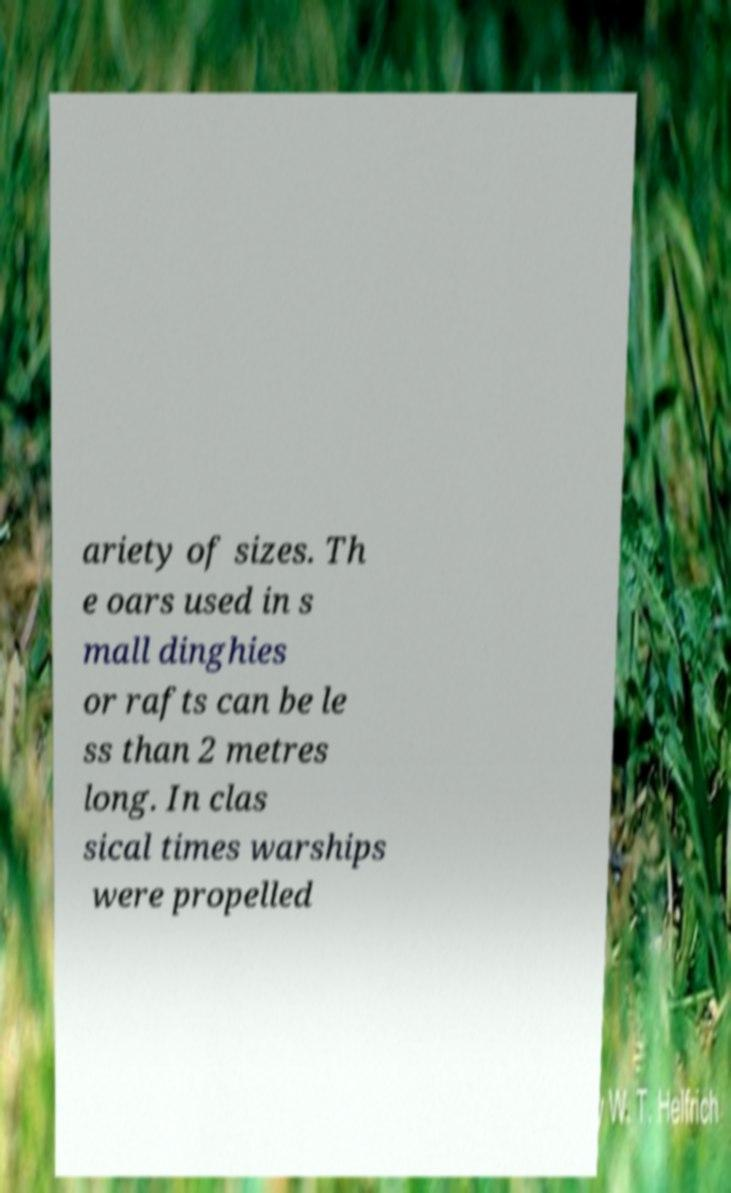I need the written content from this picture converted into text. Can you do that? ariety of sizes. Th e oars used in s mall dinghies or rafts can be le ss than 2 metres long. In clas sical times warships were propelled 